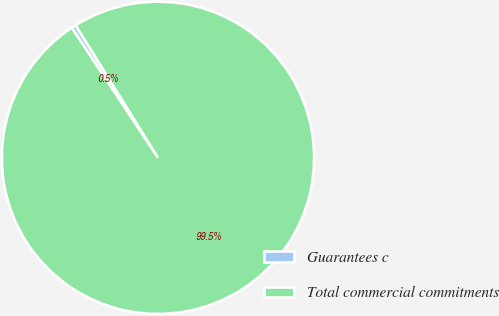<chart> <loc_0><loc_0><loc_500><loc_500><pie_chart><fcel>Guarantees c<fcel>Total commercial commitments<nl><fcel>0.47%<fcel>99.53%<nl></chart> 